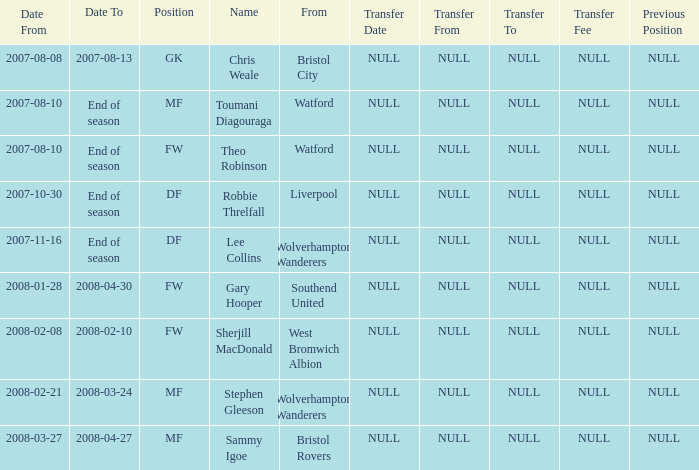What was the Date From for Theo Robinson, who was with the team until the end of season? 2007-08-10. 